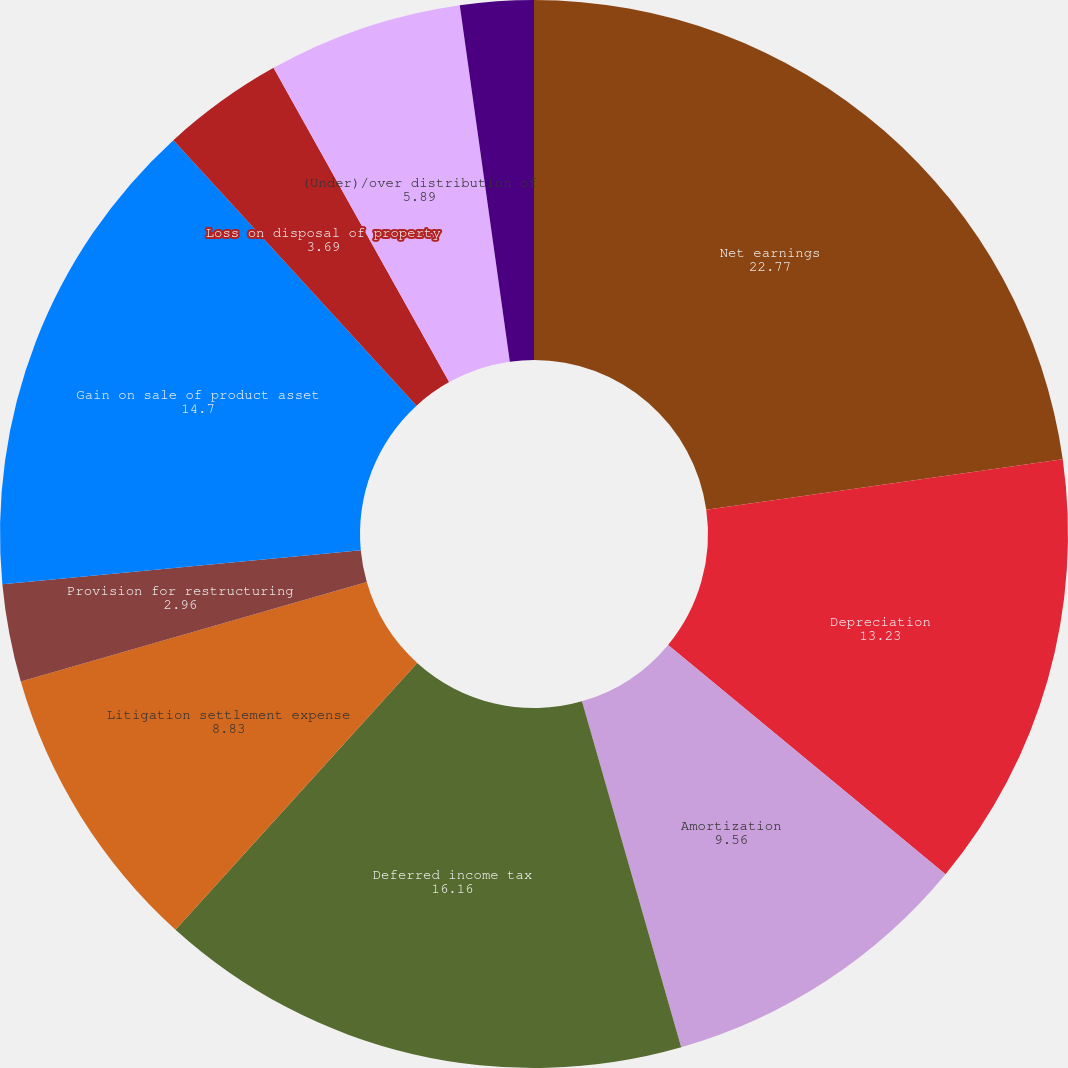Convert chart. <chart><loc_0><loc_0><loc_500><loc_500><pie_chart><fcel>Net earnings<fcel>Depreciation<fcel>Amortization<fcel>Deferred income tax<fcel>Litigation settlement expense<fcel>Provision for restructuring<fcel>Gain on sale of product asset<fcel>Loss on disposal of property<fcel>(Under)/over distribution of<fcel>Unfunded pension expense<nl><fcel>22.77%<fcel>13.23%<fcel>9.56%<fcel>16.16%<fcel>8.83%<fcel>2.96%<fcel>14.7%<fcel>3.69%<fcel>5.89%<fcel>2.22%<nl></chart> 